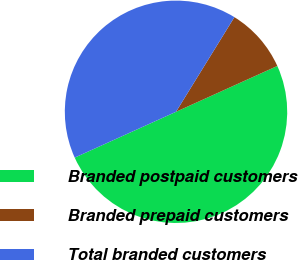Convert chart to OTSL. <chart><loc_0><loc_0><loc_500><loc_500><pie_chart><fcel>Branded postpaid customers<fcel>Branded prepaid customers<fcel>Total branded customers<nl><fcel>50.0%<fcel>9.44%<fcel>40.56%<nl></chart> 